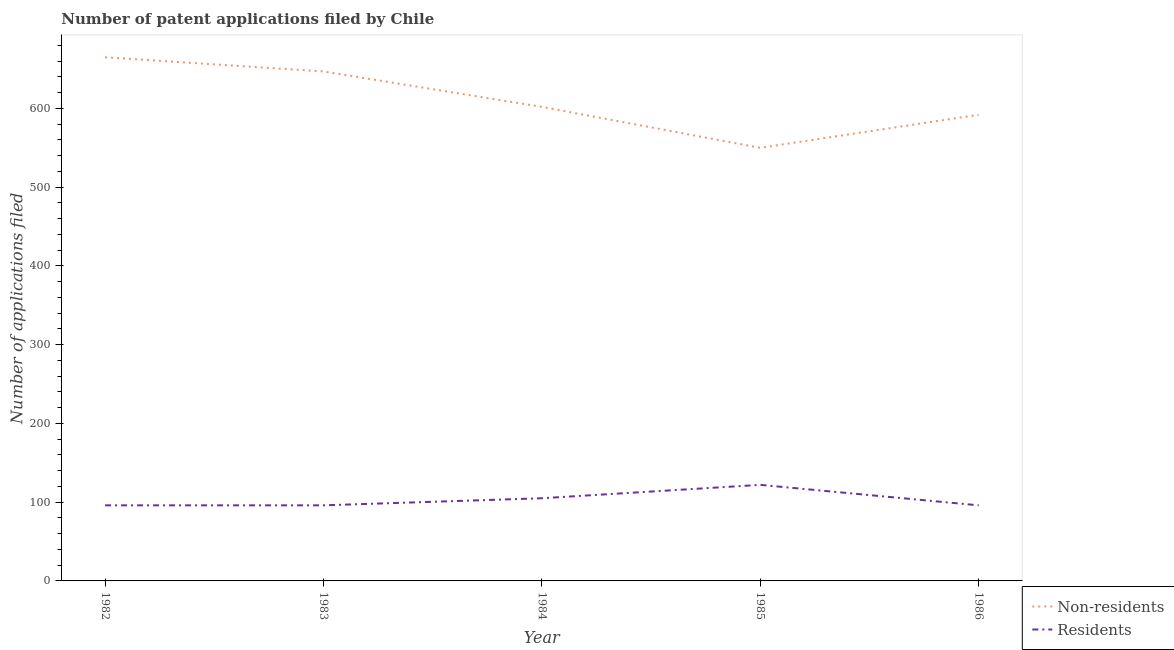Is the number of lines equal to the number of legend labels?
Make the answer very short. Yes. What is the number of patent applications by non residents in 1985?
Your answer should be very brief. 550. Across all years, what is the maximum number of patent applications by residents?
Your response must be concise. 122. Across all years, what is the minimum number of patent applications by residents?
Your answer should be compact. 96. In which year was the number of patent applications by residents maximum?
Give a very brief answer. 1985. In which year was the number of patent applications by non residents minimum?
Your answer should be compact. 1985. What is the total number of patent applications by non residents in the graph?
Give a very brief answer. 3056. What is the difference between the number of patent applications by residents in 1985 and that in 1986?
Offer a very short reply. 26. What is the difference between the number of patent applications by residents in 1983 and the number of patent applications by non residents in 1982?
Offer a terse response. -569. What is the average number of patent applications by non residents per year?
Ensure brevity in your answer.  611.2. In the year 1985, what is the difference between the number of patent applications by non residents and number of patent applications by residents?
Your response must be concise. 428. What is the ratio of the number of patent applications by non residents in 1982 to that in 1984?
Ensure brevity in your answer.  1.1. Is the difference between the number of patent applications by non residents in 1984 and 1985 greater than the difference between the number of patent applications by residents in 1984 and 1985?
Give a very brief answer. Yes. What is the difference between the highest and the lowest number of patent applications by non residents?
Your response must be concise. 115. In how many years, is the number of patent applications by residents greater than the average number of patent applications by residents taken over all years?
Your response must be concise. 2. Does the number of patent applications by non residents monotonically increase over the years?
Provide a short and direct response. No. How many lines are there?
Keep it short and to the point. 2. Does the graph contain any zero values?
Your answer should be very brief. No. How many legend labels are there?
Ensure brevity in your answer.  2. How are the legend labels stacked?
Provide a short and direct response. Vertical. What is the title of the graph?
Give a very brief answer. Number of patent applications filed by Chile. What is the label or title of the Y-axis?
Offer a very short reply. Number of applications filed. What is the Number of applications filed of Non-residents in 1982?
Your response must be concise. 665. What is the Number of applications filed of Residents in 1982?
Your answer should be compact. 96. What is the Number of applications filed in Non-residents in 1983?
Ensure brevity in your answer.  647. What is the Number of applications filed in Residents in 1983?
Provide a succinct answer. 96. What is the Number of applications filed in Non-residents in 1984?
Provide a short and direct response. 602. What is the Number of applications filed in Residents in 1984?
Your answer should be very brief. 105. What is the Number of applications filed of Non-residents in 1985?
Keep it short and to the point. 550. What is the Number of applications filed in Residents in 1985?
Make the answer very short. 122. What is the Number of applications filed of Non-residents in 1986?
Your response must be concise. 592. What is the Number of applications filed in Residents in 1986?
Provide a succinct answer. 96. Across all years, what is the maximum Number of applications filed in Non-residents?
Your answer should be compact. 665. Across all years, what is the maximum Number of applications filed in Residents?
Give a very brief answer. 122. Across all years, what is the minimum Number of applications filed in Non-residents?
Your answer should be compact. 550. Across all years, what is the minimum Number of applications filed in Residents?
Ensure brevity in your answer.  96. What is the total Number of applications filed in Non-residents in the graph?
Offer a very short reply. 3056. What is the total Number of applications filed of Residents in the graph?
Make the answer very short. 515. What is the difference between the Number of applications filed in Residents in 1982 and that in 1983?
Offer a very short reply. 0. What is the difference between the Number of applications filed of Non-residents in 1982 and that in 1984?
Offer a very short reply. 63. What is the difference between the Number of applications filed of Non-residents in 1982 and that in 1985?
Provide a succinct answer. 115. What is the difference between the Number of applications filed of Residents in 1982 and that in 1985?
Ensure brevity in your answer.  -26. What is the difference between the Number of applications filed of Non-residents in 1982 and that in 1986?
Keep it short and to the point. 73. What is the difference between the Number of applications filed in Residents in 1982 and that in 1986?
Your answer should be very brief. 0. What is the difference between the Number of applications filed of Non-residents in 1983 and that in 1984?
Give a very brief answer. 45. What is the difference between the Number of applications filed in Residents in 1983 and that in 1984?
Make the answer very short. -9. What is the difference between the Number of applications filed in Non-residents in 1983 and that in 1985?
Provide a short and direct response. 97. What is the difference between the Number of applications filed in Residents in 1983 and that in 1985?
Offer a very short reply. -26. What is the difference between the Number of applications filed in Residents in 1983 and that in 1986?
Give a very brief answer. 0. What is the difference between the Number of applications filed in Non-residents in 1984 and that in 1985?
Keep it short and to the point. 52. What is the difference between the Number of applications filed in Residents in 1984 and that in 1985?
Make the answer very short. -17. What is the difference between the Number of applications filed of Non-residents in 1985 and that in 1986?
Your answer should be very brief. -42. What is the difference between the Number of applications filed in Non-residents in 1982 and the Number of applications filed in Residents in 1983?
Your answer should be very brief. 569. What is the difference between the Number of applications filed in Non-residents in 1982 and the Number of applications filed in Residents in 1984?
Your answer should be compact. 560. What is the difference between the Number of applications filed in Non-residents in 1982 and the Number of applications filed in Residents in 1985?
Keep it short and to the point. 543. What is the difference between the Number of applications filed in Non-residents in 1982 and the Number of applications filed in Residents in 1986?
Provide a short and direct response. 569. What is the difference between the Number of applications filed in Non-residents in 1983 and the Number of applications filed in Residents in 1984?
Ensure brevity in your answer.  542. What is the difference between the Number of applications filed of Non-residents in 1983 and the Number of applications filed of Residents in 1985?
Your answer should be compact. 525. What is the difference between the Number of applications filed of Non-residents in 1983 and the Number of applications filed of Residents in 1986?
Provide a succinct answer. 551. What is the difference between the Number of applications filed in Non-residents in 1984 and the Number of applications filed in Residents in 1985?
Make the answer very short. 480. What is the difference between the Number of applications filed in Non-residents in 1984 and the Number of applications filed in Residents in 1986?
Keep it short and to the point. 506. What is the difference between the Number of applications filed in Non-residents in 1985 and the Number of applications filed in Residents in 1986?
Your answer should be compact. 454. What is the average Number of applications filed in Non-residents per year?
Offer a terse response. 611.2. What is the average Number of applications filed in Residents per year?
Your answer should be compact. 103. In the year 1982, what is the difference between the Number of applications filed in Non-residents and Number of applications filed in Residents?
Ensure brevity in your answer.  569. In the year 1983, what is the difference between the Number of applications filed of Non-residents and Number of applications filed of Residents?
Offer a very short reply. 551. In the year 1984, what is the difference between the Number of applications filed of Non-residents and Number of applications filed of Residents?
Your answer should be compact. 497. In the year 1985, what is the difference between the Number of applications filed of Non-residents and Number of applications filed of Residents?
Offer a very short reply. 428. In the year 1986, what is the difference between the Number of applications filed in Non-residents and Number of applications filed in Residents?
Your answer should be very brief. 496. What is the ratio of the Number of applications filed in Non-residents in 1982 to that in 1983?
Offer a very short reply. 1.03. What is the ratio of the Number of applications filed in Non-residents in 1982 to that in 1984?
Ensure brevity in your answer.  1.1. What is the ratio of the Number of applications filed in Residents in 1982 to that in 1984?
Ensure brevity in your answer.  0.91. What is the ratio of the Number of applications filed of Non-residents in 1982 to that in 1985?
Give a very brief answer. 1.21. What is the ratio of the Number of applications filed in Residents in 1982 to that in 1985?
Your response must be concise. 0.79. What is the ratio of the Number of applications filed in Non-residents in 1982 to that in 1986?
Offer a very short reply. 1.12. What is the ratio of the Number of applications filed of Residents in 1982 to that in 1986?
Your answer should be compact. 1. What is the ratio of the Number of applications filed in Non-residents in 1983 to that in 1984?
Provide a short and direct response. 1.07. What is the ratio of the Number of applications filed in Residents in 1983 to that in 1984?
Your answer should be very brief. 0.91. What is the ratio of the Number of applications filed of Non-residents in 1983 to that in 1985?
Keep it short and to the point. 1.18. What is the ratio of the Number of applications filed of Residents in 1983 to that in 1985?
Your answer should be compact. 0.79. What is the ratio of the Number of applications filed in Non-residents in 1983 to that in 1986?
Make the answer very short. 1.09. What is the ratio of the Number of applications filed of Non-residents in 1984 to that in 1985?
Offer a terse response. 1.09. What is the ratio of the Number of applications filed in Residents in 1984 to that in 1985?
Your response must be concise. 0.86. What is the ratio of the Number of applications filed of Non-residents in 1984 to that in 1986?
Make the answer very short. 1.02. What is the ratio of the Number of applications filed in Residents in 1984 to that in 1986?
Give a very brief answer. 1.09. What is the ratio of the Number of applications filed of Non-residents in 1985 to that in 1986?
Ensure brevity in your answer.  0.93. What is the ratio of the Number of applications filed in Residents in 1985 to that in 1986?
Provide a short and direct response. 1.27. What is the difference between the highest and the second highest Number of applications filed in Residents?
Provide a short and direct response. 17. What is the difference between the highest and the lowest Number of applications filed in Non-residents?
Give a very brief answer. 115. 